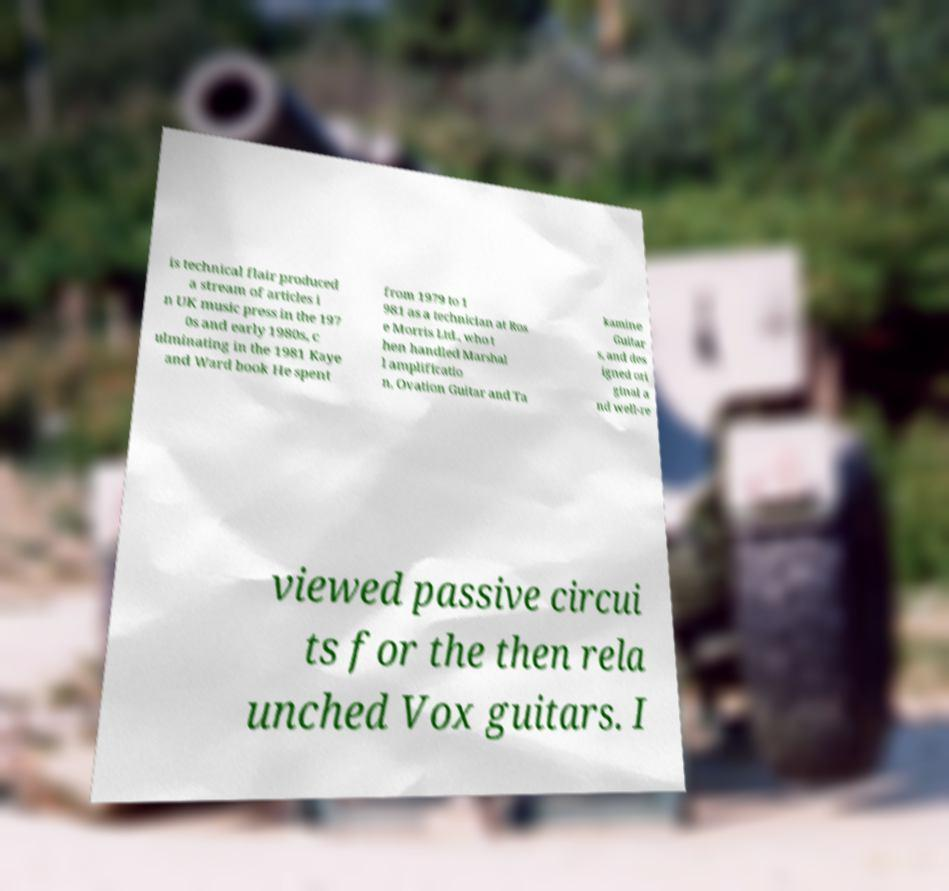Please identify and transcribe the text found in this image. is technical flair produced a stream of articles i n UK music press in the 197 0s and early 1980s, c ulminating in the 1981 Kaye and Ward book He spent from 1979 to 1 981 as a technician at Ros e Morris Ltd., who t hen handled Marshal l amplificatio n, Ovation Guitar and Ta kamine Guitar s, and des igned ori ginal a nd well-re viewed passive circui ts for the then rela unched Vox guitars. I 